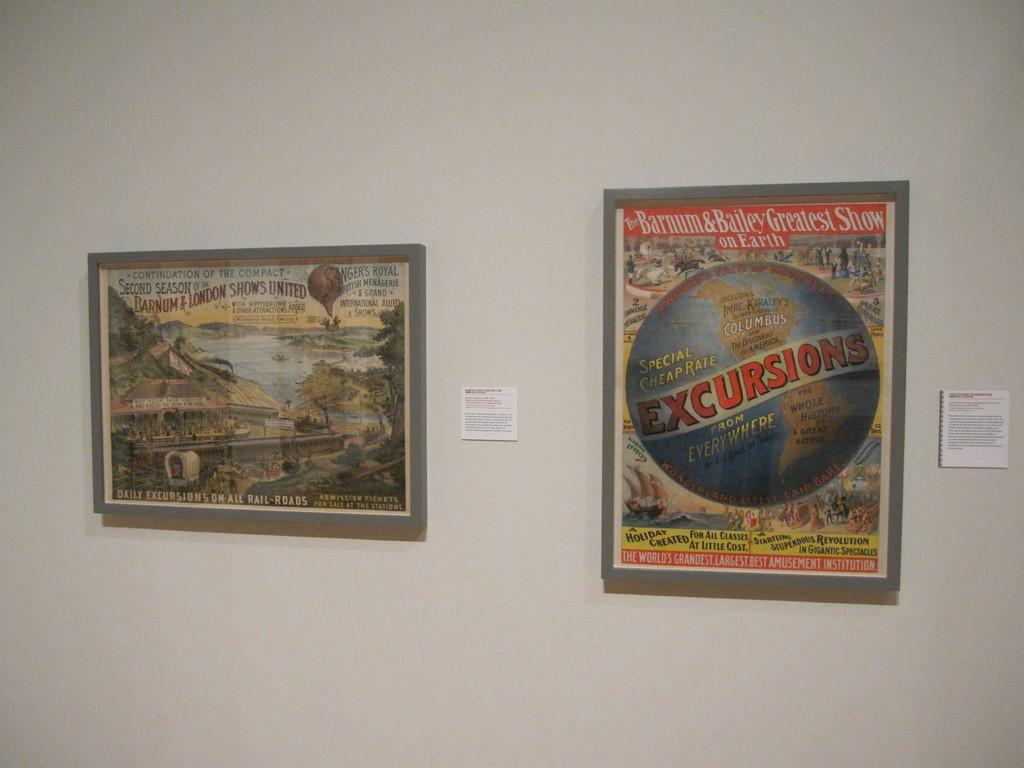What objects can be seen in the image? There are posts in the image. Where are the posts located? The posts are attached to a wall. How many dogs are playing the game on the wall in the image? There are no dogs or games present in the image; it only features posts attached to a wall. 